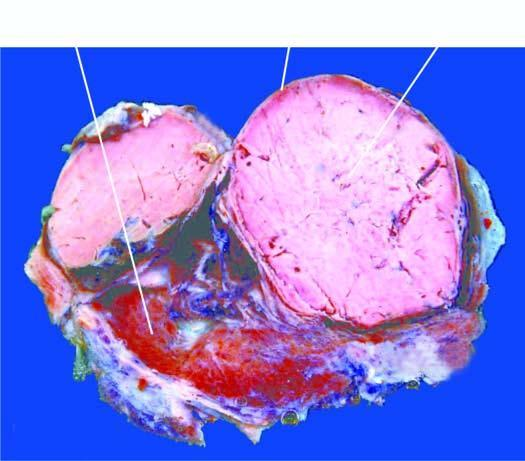does sectioned surface of the thyroid show a solitary nodule having capsule?
Answer the question using a single word or phrase. Yes 